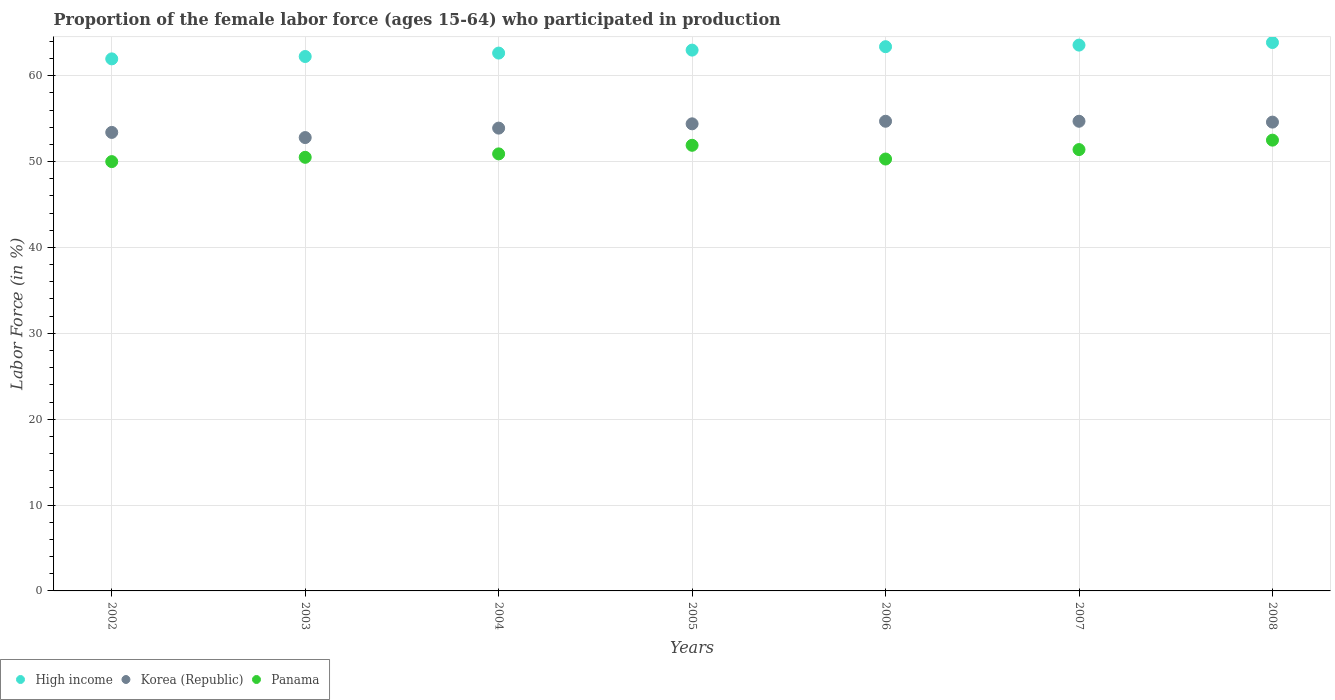What is the proportion of the female labor force who participated in production in Korea (Republic) in 2004?
Provide a succinct answer. 53.9. Across all years, what is the maximum proportion of the female labor force who participated in production in Korea (Republic)?
Keep it short and to the point. 54.7. Across all years, what is the minimum proportion of the female labor force who participated in production in High income?
Keep it short and to the point. 61.96. In which year was the proportion of the female labor force who participated in production in Panama maximum?
Offer a terse response. 2008. What is the total proportion of the female labor force who participated in production in High income in the graph?
Ensure brevity in your answer.  440.65. What is the difference between the proportion of the female labor force who participated in production in Panama in 2004 and that in 2006?
Your answer should be very brief. 0.6. What is the difference between the proportion of the female labor force who participated in production in Panama in 2006 and the proportion of the female labor force who participated in production in Korea (Republic) in 2005?
Provide a short and direct response. -4.1. What is the average proportion of the female labor force who participated in production in High income per year?
Provide a short and direct response. 62.95. In the year 2003, what is the difference between the proportion of the female labor force who participated in production in Korea (Republic) and proportion of the female labor force who participated in production in High income?
Your answer should be compact. -9.44. What is the ratio of the proportion of the female labor force who participated in production in Panama in 2007 to that in 2008?
Your answer should be very brief. 0.98. Is the proportion of the female labor force who participated in production in Korea (Republic) in 2002 less than that in 2004?
Provide a short and direct response. Yes. Is the difference between the proportion of the female labor force who participated in production in Korea (Republic) in 2004 and 2008 greater than the difference between the proportion of the female labor force who participated in production in High income in 2004 and 2008?
Provide a succinct answer. Yes. What is the difference between the highest and the second highest proportion of the female labor force who participated in production in Panama?
Provide a short and direct response. 0.6. What is the difference between the highest and the lowest proportion of the female labor force who participated in production in High income?
Keep it short and to the point. 1.9. Is the sum of the proportion of the female labor force who participated in production in Korea (Republic) in 2002 and 2004 greater than the maximum proportion of the female labor force who participated in production in Panama across all years?
Offer a terse response. Yes. Is the proportion of the female labor force who participated in production in Korea (Republic) strictly greater than the proportion of the female labor force who participated in production in Panama over the years?
Your answer should be compact. Yes. How many dotlines are there?
Provide a succinct answer. 3. How many years are there in the graph?
Your answer should be compact. 7. What is the difference between two consecutive major ticks on the Y-axis?
Your answer should be compact. 10. Are the values on the major ticks of Y-axis written in scientific E-notation?
Provide a succinct answer. No. How many legend labels are there?
Your answer should be very brief. 3. How are the legend labels stacked?
Offer a very short reply. Horizontal. What is the title of the graph?
Your answer should be very brief. Proportion of the female labor force (ages 15-64) who participated in production. What is the label or title of the Y-axis?
Your answer should be compact. Labor Force (in %). What is the Labor Force (in %) of High income in 2002?
Keep it short and to the point. 61.96. What is the Labor Force (in %) in Korea (Republic) in 2002?
Your answer should be very brief. 53.4. What is the Labor Force (in %) of Panama in 2002?
Keep it short and to the point. 50. What is the Labor Force (in %) in High income in 2003?
Ensure brevity in your answer.  62.24. What is the Labor Force (in %) of Korea (Republic) in 2003?
Offer a very short reply. 52.8. What is the Labor Force (in %) of Panama in 2003?
Your answer should be very brief. 50.5. What is the Labor Force (in %) of High income in 2004?
Your answer should be very brief. 62.64. What is the Labor Force (in %) in Korea (Republic) in 2004?
Offer a terse response. 53.9. What is the Labor Force (in %) in Panama in 2004?
Ensure brevity in your answer.  50.9. What is the Labor Force (in %) of High income in 2005?
Offer a very short reply. 62.99. What is the Labor Force (in %) in Korea (Republic) in 2005?
Offer a very short reply. 54.4. What is the Labor Force (in %) of Panama in 2005?
Make the answer very short. 51.9. What is the Labor Force (in %) of High income in 2006?
Provide a succinct answer. 63.38. What is the Labor Force (in %) in Korea (Republic) in 2006?
Your answer should be compact. 54.7. What is the Labor Force (in %) in Panama in 2006?
Give a very brief answer. 50.3. What is the Labor Force (in %) in High income in 2007?
Keep it short and to the point. 63.57. What is the Labor Force (in %) of Korea (Republic) in 2007?
Provide a short and direct response. 54.7. What is the Labor Force (in %) in Panama in 2007?
Your response must be concise. 51.4. What is the Labor Force (in %) of High income in 2008?
Your response must be concise. 63.87. What is the Labor Force (in %) in Korea (Republic) in 2008?
Keep it short and to the point. 54.6. What is the Labor Force (in %) of Panama in 2008?
Provide a short and direct response. 52.5. Across all years, what is the maximum Labor Force (in %) of High income?
Provide a short and direct response. 63.87. Across all years, what is the maximum Labor Force (in %) in Korea (Republic)?
Your answer should be very brief. 54.7. Across all years, what is the maximum Labor Force (in %) of Panama?
Provide a short and direct response. 52.5. Across all years, what is the minimum Labor Force (in %) of High income?
Your answer should be compact. 61.96. Across all years, what is the minimum Labor Force (in %) of Korea (Republic)?
Provide a succinct answer. 52.8. What is the total Labor Force (in %) of High income in the graph?
Keep it short and to the point. 440.65. What is the total Labor Force (in %) in Korea (Republic) in the graph?
Your answer should be compact. 378.5. What is the total Labor Force (in %) of Panama in the graph?
Your answer should be very brief. 357.5. What is the difference between the Labor Force (in %) of High income in 2002 and that in 2003?
Provide a short and direct response. -0.28. What is the difference between the Labor Force (in %) of Korea (Republic) in 2002 and that in 2003?
Provide a short and direct response. 0.6. What is the difference between the Labor Force (in %) of High income in 2002 and that in 2004?
Offer a terse response. -0.67. What is the difference between the Labor Force (in %) of Panama in 2002 and that in 2004?
Offer a terse response. -0.9. What is the difference between the Labor Force (in %) of High income in 2002 and that in 2005?
Make the answer very short. -1.02. What is the difference between the Labor Force (in %) in Panama in 2002 and that in 2005?
Your answer should be very brief. -1.9. What is the difference between the Labor Force (in %) in High income in 2002 and that in 2006?
Keep it short and to the point. -1.42. What is the difference between the Labor Force (in %) in High income in 2002 and that in 2007?
Your answer should be compact. -1.6. What is the difference between the Labor Force (in %) of Korea (Republic) in 2002 and that in 2007?
Offer a terse response. -1.3. What is the difference between the Labor Force (in %) in High income in 2002 and that in 2008?
Provide a short and direct response. -1.9. What is the difference between the Labor Force (in %) in Korea (Republic) in 2002 and that in 2008?
Provide a short and direct response. -1.2. What is the difference between the Labor Force (in %) in Panama in 2002 and that in 2008?
Your response must be concise. -2.5. What is the difference between the Labor Force (in %) of High income in 2003 and that in 2004?
Ensure brevity in your answer.  -0.4. What is the difference between the Labor Force (in %) in High income in 2003 and that in 2005?
Offer a terse response. -0.74. What is the difference between the Labor Force (in %) of Korea (Republic) in 2003 and that in 2005?
Make the answer very short. -1.6. What is the difference between the Labor Force (in %) of Panama in 2003 and that in 2005?
Provide a succinct answer. -1.4. What is the difference between the Labor Force (in %) in High income in 2003 and that in 2006?
Your response must be concise. -1.14. What is the difference between the Labor Force (in %) in High income in 2003 and that in 2007?
Provide a short and direct response. -1.33. What is the difference between the Labor Force (in %) in Panama in 2003 and that in 2007?
Offer a very short reply. -0.9. What is the difference between the Labor Force (in %) of High income in 2003 and that in 2008?
Ensure brevity in your answer.  -1.63. What is the difference between the Labor Force (in %) in Korea (Republic) in 2003 and that in 2008?
Ensure brevity in your answer.  -1.8. What is the difference between the Labor Force (in %) in High income in 2004 and that in 2005?
Keep it short and to the point. -0.35. What is the difference between the Labor Force (in %) of Korea (Republic) in 2004 and that in 2005?
Offer a terse response. -0.5. What is the difference between the Labor Force (in %) in Panama in 2004 and that in 2005?
Ensure brevity in your answer.  -1. What is the difference between the Labor Force (in %) of High income in 2004 and that in 2006?
Ensure brevity in your answer.  -0.74. What is the difference between the Labor Force (in %) in Panama in 2004 and that in 2006?
Keep it short and to the point. 0.6. What is the difference between the Labor Force (in %) in High income in 2004 and that in 2007?
Keep it short and to the point. -0.93. What is the difference between the Labor Force (in %) of Panama in 2004 and that in 2007?
Provide a short and direct response. -0.5. What is the difference between the Labor Force (in %) in High income in 2004 and that in 2008?
Make the answer very short. -1.23. What is the difference between the Labor Force (in %) of Korea (Republic) in 2004 and that in 2008?
Provide a short and direct response. -0.7. What is the difference between the Labor Force (in %) of High income in 2005 and that in 2006?
Provide a short and direct response. -0.4. What is the difference between the Labor Force (in %) of Panama in 2005 and that in 2006?
Offer a terse response. 1.6. What is the difference between the Labor Force (in %) in High income in 2005 and that in 2007?
Provide a succinct answer. -0.58. What is the difference between the Labor Force (in %) in High income in 2005 and that in 2008?
Provide a succinct answer. -0.88. What is the difference between the Labor Force (in %) in Korea (Republic) in 2005 and that in 2008?
Your response must be concise. -0.2. What is the difference between the Labor Force (in %) of High income in 2006 and that in 2007?
Your answer should be compact. -0.19. What is the difference between the Labor Force (in %) in High income in 2006 and that in 2008?
Give a very brief answer. -0.49. What is the difference between the Labor Force (in %) in High income in 2007 and that in 2008?
Ensure brevity in your answer.  -0.3. What is the difference between the Labor Force (in %) in Korea (Republic) in 2007 and that in 2008?
Provide a succinct answer. 0.1. What is the difference between the Labor Force (in %) of Panama in 2007 and that in 2008?
Keep it short and to the point. -1.1. What is the difference between the Labor Force (in %) in High income in 2002 and the Labor Force (in %) in Korea (Republic) in 2003?
Give a very brief answer. 9.16. What is the difference between the Labor Force (in %) in High income in 2002 and the Labor Force (in %) in Panama in 2003?
Offer a very short reply. 11.46. What is the difference between the Labor Force (in %) in Korea (Republic) in 2002 and the Labor Force (in %) in Panama in 2003?
Ensure brevity in your answer.  2.9. What is the difference between the Labor Force (in %) in High income in 2002 and the Labor Force (in %) in Korea (Republic) in 2004?
Give a very brief answer. 8.06. What is the difference between the Labor Force (in %) in High income in 2002 and the Labor Force (in %) in Panama in 2004?
Your answer should be very brief. 11.06. What is the difference between the Labor Force (in %) of High income in 2002 and the Labor Force (in %) of Korea (Republic) in 2005?
Give a very brief answer. 7.56. What is the difference between the Labor Force (in %) in High income in 2002 and the Labor Force (in %) in Panama in 2005?
Ensure brevity in your answer.  10.06. What is the difference between the Labor Force (in %) in High income in 2002 and the Labor Force (in %) in Korea (Republic) in 2006?
Your response must be concise. 7.26. What is the difference between the Labor Force (in %) of High income in 2002 and the Labor Force (in %) of Panama in 2006?
Your answer should be very brief. 11.66. What is the difference between the Labor Force (in %) in Korea (Republic) in 2002 and the Labor Force (in %) in Panama in 2006?
Give a very brief answer. 3.1. What is the difference between the Labor Force (in %) of High income in 2002 and the Labor Force (in %) of Korea (Republic) in 2007?
Offer a terse response. 7.26. What is the difference between the Labor Force (in %) in High income in 2002 and the Labor Force (in %) in Panama in 2007?
Offer a very short reply. 10.56. What is the difference between the Labor Force (in %) in High income in 2002 and the Labor Force (in %) in Korea (Republic) in 2008?
Keep it short and to the point. 7.36. What is the difference between the Labor Force (in %) of High income in 2002 and the Labor Force (in %) of Panama in 2008?
Make the answer very short. 9.46. What is the difference between the Labor Force (in %) in Korea (Republic) in 2002 and the Labor Force (in %) in Panama in 2008?
Your answer should be compact. 0.9. What is the difference between the Labor Force (in %) of High income in 2003 and the Labor Force (in %) of Korea (Republic) in 2004?
Your response must be concise. 8.34. What is the difference between the Labor Force (in %) of High income in 2003 and the Labor Force (in %) of Panama in 2004?
Keep it short and to the point. 11.34. What is the difference between the Labor Force (in %) in Korea (Republic) in 2003 and the Labor Force (in %) in Panama in 2004?
Your response must be concise. 1.9. What is the difference between the Labor Force (in %) of High income in 2003 and the Labor Force (in %) of Korea (Republic) in 2005?
Ensure brevity in your answer.  7.84. What is the difference between the Labor Force (in %) in High income in 2003 and the Labor Force (in %) in Panama in 2005?
Keep it short and to the point. 10.34. What is the difference between the Labor Force (in %) of Korea (Republic) in 2003 and the Labor Force (in %) of Panama in 2005?
Ensure brevity in your answer.  0.9. What is the difference between the Labor Force (in %) in High income in 2003 and the Labor Force (in %) in Korea (Republic) in 2006?
Make the answer very short. 7.54. What is the difference between the Labor Force (in %) of High income in 2003 and the Labor Force (in %) of Panama in 2006?
Make the answer very short. 11.94. What is the difference between the Labor Force (in %) of Korea (Republic) in 2003 and the Labor Force (in %) of Panama in 2006?
Your response must be concise. 2.5. What is the difference between the Labor Force (in %) of High income in 2003 and the Labor Force (in %) of Korea (Republic) in 2007?
Ensure brevity in your answer.  7.54. What is the difference between the Labor Force (in %) in High income in 2003 and the Labor Force (in %) in Panama in 2007?
Keep it short and to the point. 10.84. What is the difference between the Labor Force (in %) of High income in 2003 and the Labor Force (in %) of Korea (Republic) in 2008?
Your answer should be compact. 7.64. What is the difference between the Labor Force (in %) of High income in 2003 and the Labor Force (in %) of Panama in 2008?
Your answer should be very brief. 9.74. What is the difference between the Labor Force (in %) in High income in 2004 and the Labor Force (in %) in Korea (Republic) in 2005?
Provide a succinct answer. 8.24. What is the difference between the Labor Force (in %) in High income in 2004 and the Labor Force (in %) in Panama in 2005?
Your answer should be compact. 10.74. What is the difference between the Labor Force (in %) of High income in 2004 and the Labor Force (in %) of Korea (Republic) in 2006?
Offer a very short reply. 7.94. What is the difference between the Labor Force (in %) in High income in 2004 and the Labor Force (in %) in Panama in 2006?
Offer a terse response. 12.34. What is the difference between the Labor Force (in %) of Korea (Republic) in 2004 and the Labor Force (in %) of Panama in 2006?
Provide a succinct answer. 3.6. What is the difference between the Labor Force (in %) in High income in 2004 and the Labor Force (in %) in Korea (Republic) in 2007?
Your answer should be compact. 7.94. What is the difference between the Labor Force (in %) of High income in 2004 and the Labor Force (in %) of Panama in 2007?
Keep it short and to the point. 11.24. What is the difference between the Labor Force (in %) in Korea (Republic) in 2004 and the Labor Force (in %) in Panama in 2007?
Your response must be concise. 2.5. What is the difference between the Labor Force (in %) of High income in 2004 and the Labor Force (in %) of Korea (Republic) in 2008?
Make the answer very short. 8.04. What is the difference between the Labor Force (in %) in High income in 2004 and the Labor Force (in %) in Panama in 2008?
Offer a terse response. 10.14. What is the difference between the Labor Force (in %) of Korea (Republic) in 2004 and the Labor Force (in %) of Panama in 2008?
Give a very brief answer. 1.4. What is the difference between the Labor Force (in %) of High income in 2005 and the Labor Force (in %) of Korea (Republic) in 2006?
Your response must be concise. 8.29. What is the difference between the Labor Force (in %) of High income in 2005 and the Labor Force (in %) of Panama in 2006?
Provide a short and direct response. 12.69. What is the difference between the Labor Force (in %) of Korea (Republic) in 2005 and the Labor Force (in %) of Panama in 2006?
Offer a terse response. 4.1. What is the difference between the Labor Force (in %) of High income in 2005 and the Labor Force (in %) of Korea (Republic) in 2007?
Keep it short and to the point. 8.29. What is the difference between the Labor Force (in %) of High income in 2005 and the Labor Force (in %) of Panama in 2007?
Provide a succinct answer. 11.59. What is the difference between the Labor Force (in %) of High income in 2005 and the Labor Force (in %) of Korea (Republic) in 2008?
Make the answer very short. 8.39. What is the difference between the Labor Force (in %) of High income in 2005 and the Labor Force (in %) of Panama in 2008?
Offer a very short reply. 10.49. What is the difference between the Labor Force (in %) in Korea (Republic) in 2005 and the Labor Force (in %) in Panama in 2008?
Your answer should be very brief. 1.9. What is the difference between the Labor Force (in %) in High income in 2006 and the Labor Force (in %) in Korea (Republic) in 2007?
Provide a short and direct response. 8.68. What is the difference between the Labor Force (in %) of High income in 2006 and the Labor Force (in %) of Panama in 2007?
Provide a succinct answer. 11.98. What is the difference between the Labor Force (in %) in Korea (Republic) in 2006 and the Labor Force (in %) in Panama in 2007?
Ensure brevity in your answer.  3.3. What is the difference between the Labor Force (in %) of High income in 2006 and the Labor Force (in %) of Korea (Republic) in 2008?
Make the answer very short. 8.78. What is the difference between the Labor Force (in %) of High income in 2006 and the Labor Force (in %) of Panama in 2008?
Offer a terse response. 10.88. What is the difference between the Labor Force (in %) of Korea (Republic) in 2006 and the Labor Force (in %) of Panama in 2008?
Keep it short and to the point. 2.2. What is the difference between the Labor Force (in %) of High income in 2007 and the Labor Force (in %) of Korea (Republic) in 2008?
Your answer should be very brief. 8.97. What is the difference between the Labor Force (in %) of High income in 2007 and the Labor Force (in %) of Panama in 2008?
Ensure brevity in your answer.  11.07. What is the difference between the Labor Force (in %) of Korea (Republic) in 2007 and the Labor Force (in %) of Panama in 2008?
Provide a succinct answer. 2.2. What is the average Labor Force (in %) in High income per year?
Give a very brief answer. 62.95. What is the average Labor Force (in %) in Korea (Republic) per year?
Provide a succinct answer. 54.07. What is the average Labor Force (in %) in Panama per year?
Keep it short and to the point. 51.07. In the year 2002, what is the difference between the Labor Force (in %) of High income and Labor Force (in %) of Korea (Republic)?
Your answer should be very brief. 8.56. In the year 2002, what is the difference between the Labor Force (in %) in High income and Labor Force (in %) in Panama?
Keep it short and to the point. 11.96. In the year 2002, what is the difference between the Labor Force (in %) of Korea (Republic) and Labor Force (in %) of Panama?
Ensure brevity in your answer.  3.4. In the year 2003, what is the difference between the Labor Force (in %) in High income and Labor Force (in %) in Korea (Republic)?
Make the answer very short. 9.44. In the year 2003, what is the difference between the Labor Force (in %) of High income and Labor Force (in %) of Panama?
Give a very brief answer. 11.74. In the year 2003, what is the difference between the Labor Force (in %) of Korea (Republic) and Labor Force (in %) of Panama?
Ensure brevity in your answer.  2.3. In the year 2004, what is the difference between the Labor Force (in %) in High income and Labor Force (in %) in Korea (Republic)?
Give a very brief answer. 8.74. In the year 2004, what is the difference between the Labor Force (in %) of High income and Labor Force (in %) of Panama?
Offer a very short reply. 11.74. In the year 2004, what is the difference between the Labor Force (in %) in Korea (Republic) and Labor Force (in %) in Panama?
Your answer should be very brief. 3. In the year 2005, what is the difference between the Labor Force (in %) of High income and Labor Force (in %) of Korea (Republic)?
Ensure brevity in your answer.  8.59. In the year 2005, what is the difference between the Labor Force (in %) in High income and Labor Force (in %) in Panama?
Provide a short and direct response. 11.09. In the year 2005, what is the difference between the Labor Force (in %) of Korea (Republic) and Labor Force (in %) of Panama?
Ensure brevity in your answer.  2.5. In the year 2006, what is the difference between the Labor Force (in %) in High income and Labor Force (in %) in Korea (Republic)?
Make the answer very short. 8.68. In the year 2006, what is the difference between the Labor Force (in %) of High income and Labor Force (in %) of Panama?
Provide a succinct answer. 13.08. In the year 2006, what is the difference between the Labor Force (in %) in Korea (Republic) and Labor Force (in %) in Panama?
Provide a short and direct response. 4.4. In the year 2007, what is the difference between the Labor Force (in %) in High income and Labor Force (in %) in Korea (Republic)?
Provide a short and direct response. 8.87. In the year 2007, what is the difference between the Labor Force (in %) of High income and Labor Force (in %) of Panama?
Make the answer very short. 12.17. In the year 2007, what is the difference between the Labor Force (in %) of Korea (Republic) and Labor Force (in %) of Panama?
Offer a terse response. 3.3. In the year 2008, what is the difference between the Labor Force (in %) in High income and Labor Force (in %) in Korea (Republic)?
Give a very brief answer. 9.27. In the year 2008, what is the difference between the Labor Force (in %) of High income and Labor Force (in %) of Panama?
Give a very brief answer. 11.37. What is the ratio of the Labor Force (in %) of Korea (Republic) in 2002 to that in 2003?
Your response must be concise. 1.01. What is the ratio of the Labor Force (in %) in Panama in 2002 to that in 2003?
Your response must be concise. 0.99. What is the ratio of the Labor Force (in %) in Panama in 2002 to that in 2004?
Give a very brief answer. 0.98. What is the ratio of the Labor Force (in %) in High income in 2002 to that in 2005?
Your response must be concise. 0.98. What is the ratio of the Labor Force (in %) of Korea (Republic) in 2002 to that in 2005?
Your answer should be compact. 0.98. What is the ratio of the Labor Force (in %) in Panama in 2002 to that in 2005?
Your response must be concise. 0.96. What is the ratio of the Labor Force (in %) in High income in 2002 to that in 2006?
Make the answer very short. 0.98. What is the ratio of the Labor Force (in %) of Korea (Republic) in 2002 to that in 2006?
Make the answer very short. 0.98. What is the ratio of the Labor Force (in %) of Panama in 2002 to that in 2006?
Make the answer very short. 0.99. What is the ratio of the Labor Force (in %) of High income in 2002 to that in 2007?
Your answer should be very brief. 0.97. What is the ratio of the Labor Force (in %) in Korea (Republic) in 2002 to that in 2007?
Ensure brevity in your answer.  0.98. What is the ratio of the Labor Force (in %) of Panama in 2002 to that in 2007?
Give a very brief answer. 0.97. What is the ratio of the Labor Force (in %) in High income in 2002 to that in 2008?
Offer a terse response. 0.97. What is the ratio of the Labor Force (in %) in Panama in 2002 to that in 2008?
Offer a terse response. 0.95. What is the ratio of the Labor Force (in %) of Korea (Republic) in 2003 to that in 2004?
Give a very brief answer. 0.98. What is the ratio of the Labor Force (in %) in Panama in 2003 to that in 2004?
Provide a succinct answer. 0.99. What is the ratio of the Labor Force (in %) of High income in 2003 to that in 2005?
Make the answer very short. 0.99. What is the ratio of the Labor Force (in %) of Korea (Republic) in 2003 to that in 2005?
Provide a succinct answer. 0.97. What is the ratio of the Labor Force (in %) in High income in 2003 to that in 2006?
Keep it short and to the point. 0.98. What is the ratio of the Labor Force (in %) in Korea (Republic) in 2003 to that in 2006?
Ensure brevity in your answer.  0.97. What is the ratio of the Labor Force (in %) in Panama in 2003 to that in 2006?
Your answer should be very brief. 1. What is the ratio of the Labor Force (in %) of High income in 2003 to that in 2007?
Keep it short and to the point. 0.98. What is the ratio of the Labor Force (in %) in Korea (Republic) in 2003 to that in 2007?
Offer a very short reply. 0.97. What is the ratio of the Labor Force (in %) in Panama in 2003 to that in 2007?
Your answer should be very brief. 0.98. What is the ratio of the Labor Force (in %) in High income in 2003 to that in 2008?
Offer a very short reply. 0.97. What is the ratio of the Labor Force (in %) in Korea (Republic) in 2003 to that in 2008?
Offer a terse response. 0.97. What is the ratio of the Labor Force (in %) of Panama in 2003 to that in 2008?
Your response must be concise. 0.96. What is the ratio of the Labor Force (in %) of High income in 2004 to that in 2005?
Provide a succinct answer. 0.99. What is the ratio of the Labor Force (in %) in Korea (Republic) in 2004 to that in 2005?
Keep it short and to the point. 0.99. What is the ratio of the Labor Force (in %) in Panama in 2004 to that in 2005?
Ensure brevity in your answer.  0.98. What is the ratio of the Labor Force (in %) in High income in 2004 to that in 2006?
Make the answer very short. 0.99. What is the ratio of the Labor Force (in %) of Korea (Republic) in 2004 to that in 2006?
Your answer should be compact. 0.99. What is the ratio of the Labor Force (in %) of Panama in 2004 to that in 2006?
Give a very brief answer. 1.01. What is the ratio of the Labor Force (in %) of High income in 2004 to that in 2007?
Ensure brevity in your answer.  0.99. What is the ratio of the Labor Force (in %) in Korea (Republic) in 2004 to that in 2007?
Your answer should be compact. 0.99. What is the ratio of the Labor Force (in %) in Panama in 2004 to that in 2007?
Offer a very short reply. 0.99. What is the ratio of the Labor Force (in %) of High income in 2004 to that in 2008?
Provide a succinct answer. 0.98. What is the ratio of the Labor Force (in %) in Korea (Republic) in 2004 to that in 2008?
Your answer should be compact. 0.99. What is the ratio of the Labor Force (in %) in Panama in 2004 to that in 2008?
Provide a short and direct response. 0.97. What is the ratio of the Labor Force (in %) of Panama in 2005 to that in 2006?
Your answer should be compact. 1.03. What is the ratio of the Labor Force (in %) in High income in 2005 to that in 2007?
Offer a very short reply. 0.99. What is the ratio of the Labor Force (in %) of Panama in 2005 to that in 2007?
Keep it short and to the point. 1.01. What is the ratio of the Labor Force (in %) of High income in 2005 to that in 2008?
Offer a terse response. 0.99. What is the ratio of the Labor Force (in %) in Korea (Republic) in 2005 to that in 2008?
Provide a succinct answer. 1. What is the ratio of the Labor Force (in %) in Korea (Republic) in 2006 to that in 2007?
Give a very brief answer. 1. What is the ratio of the Labor Force (in %) of Panama in 2006 to that in 2007?
Ensure brevity in your answer.  0.98. What is the ratio of the Labor Force (in %) in Korea (Republic) in 2006 to that in 2008?
Your response must be concise. 1. What is the ratio of the Labor Force (in %) of Panama in 2006 to that in 2008?
Your answer should be compact. 0.96. What is the ratio of the Labor Force (in %) of High income in 2007 to that in 2008?
Your answer should be compact. 1. What is the difference between the highest and the second highest Labor Force (in %) of High income?
Provide a succinct answer. 0.3. What is the difference between the highest and the second highest Labor Force (in %) in Korea (Republic)?
Your response must be concise. 0. What is the difference between the highest and the lowest Labor Force (in %) in High income?
Give a very brief answer. 1.9. What is the difference between the highest and the lowest Labor Force (in %) in Panama?
Your answer should be very brief. 2.5. 